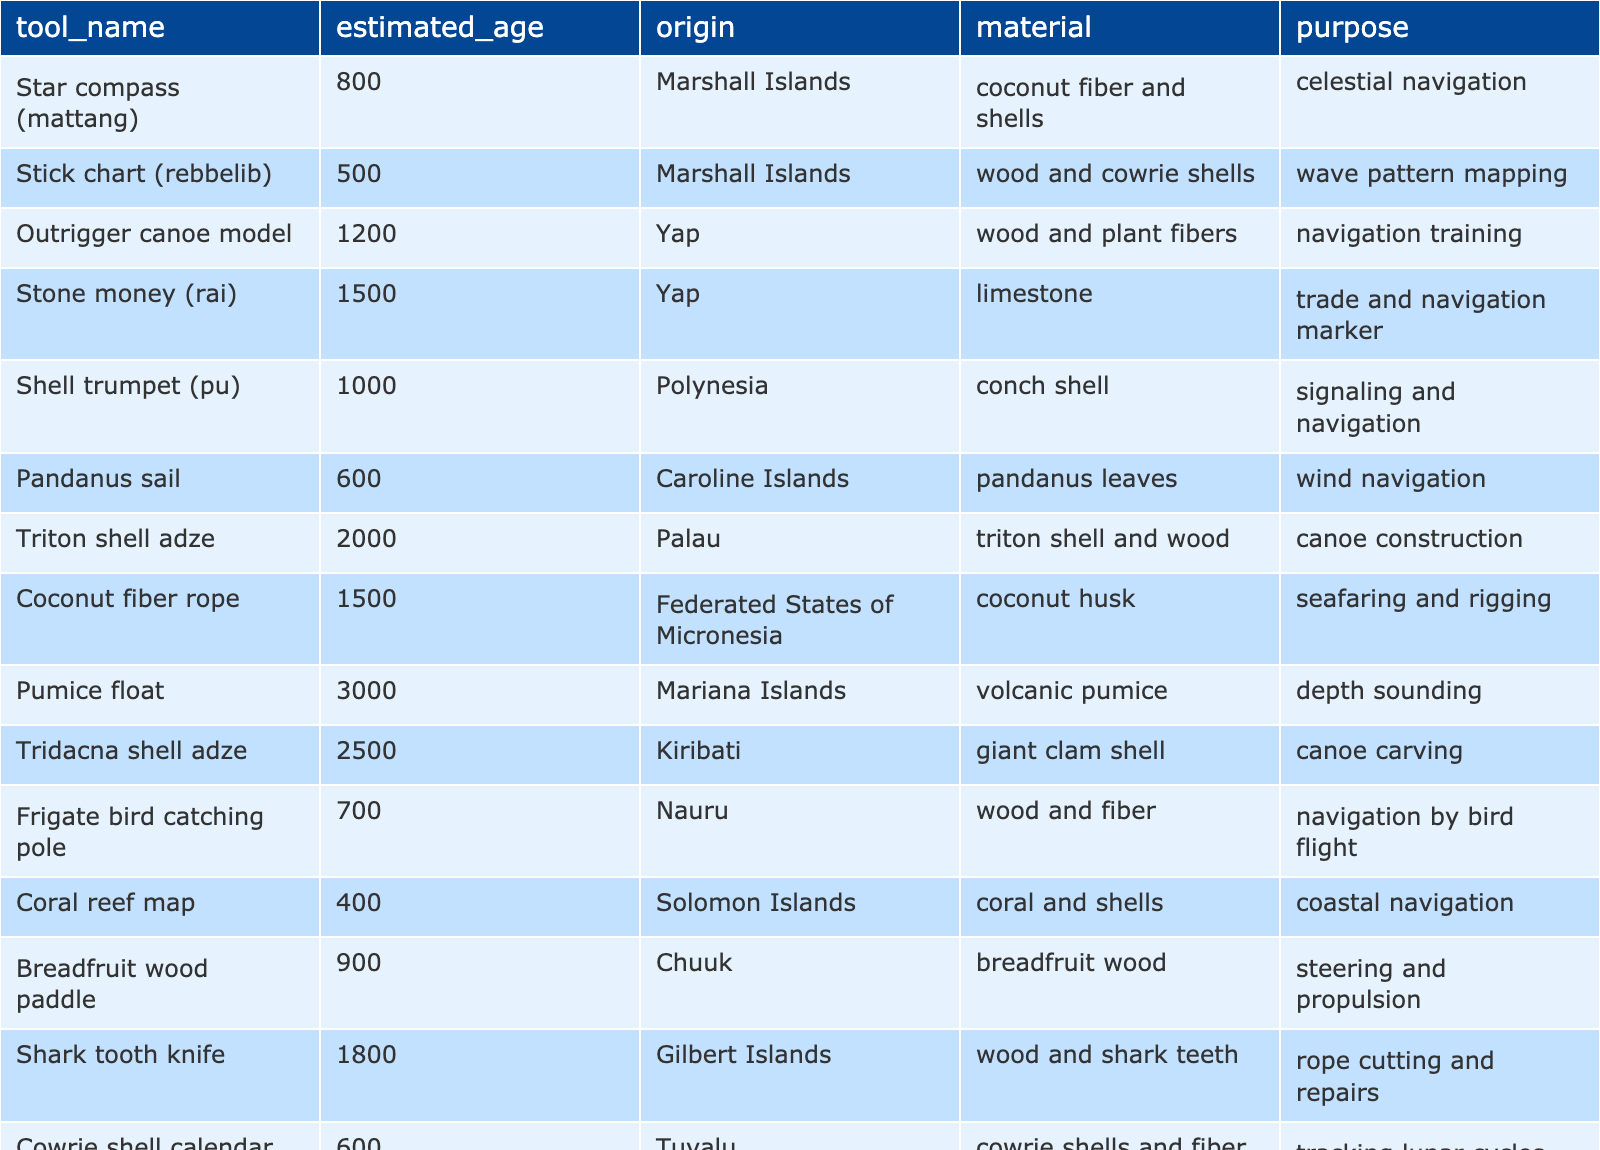What is the estimated age of the Star compass? The table lists the estimated age of the Star compass (mattang) as 800 years.
Answer: 800 years Which tool has the oldest estimated age? The table shows that the Pumice float has the oldest estimated age at 3000 years.
Answer: Pumice float How many tools originate from the Marshall Islands? From the table, there are two tools from the Marshall Islands: the Star compass and the Stick chart.
Answer: 2 tools What material is used for the Outrigger canoe model? The table indicates the Outrigger canoe model is made of wood and plant fibers.
Answer: Wood and plant fibers Is the Cowrie shell calendar used for navigation? The table states the Cowrie shell calendar is used for tracking lunar cycles for navigation, indicating a yes.
Answer: Yes Which tool has an estimated age of 1500 years? According to the table, both Stone money and Coconut fiber rope have an estimated age of 1500 years.
Answer: Stone money, Coconut fiber rope What is the primary purpose of the Shell trumpet? The table shows that the Shell trumpet (pu) is used for signaling and navigation.
Answer: Signaling and navigation What percentage of the tools are made from organic materials? The table has 14 tools, out of which 10 are made from organic materials (like wood, coconut fiber, and shells). Thus, the percentage is (10/14)*100 = 71.43%.
Answer: 71.43% Which tool comes from the Caroline Islands, and what is its estimated age? The Pandanus sail comes from the Caroline Islands, and its estimated age is 600 years.
Answer: Pandanus sail, 600 years If we sum up the estimated ages of tools from Yap, what total do we get? The tools from Yap are the Outrigger canoe model (1200) and Stone money (1500). Summing them gives 1200 + 1500 = 2700.
Answer: 2700 years Which tool is used for wave pattern mapping? The Stick chart (rebbelib) is specified in the table as the tool used for wave pattern mapping.
Answer: Stick chart What is the estimated age difference between the Triton shell adze and the Tridacna shell adze? The Triton shell adze has an estimated age of 2000 years, and the Tridacna shell adze has an estimated age of 2500 years. The difference is 2500 - 2000 = 500 years.
Answer: 500 years Is there any tool made from limestone? Yes, the Stone money (rai) is made from limestone, confirming the statement to be true.
Answer: Yes 